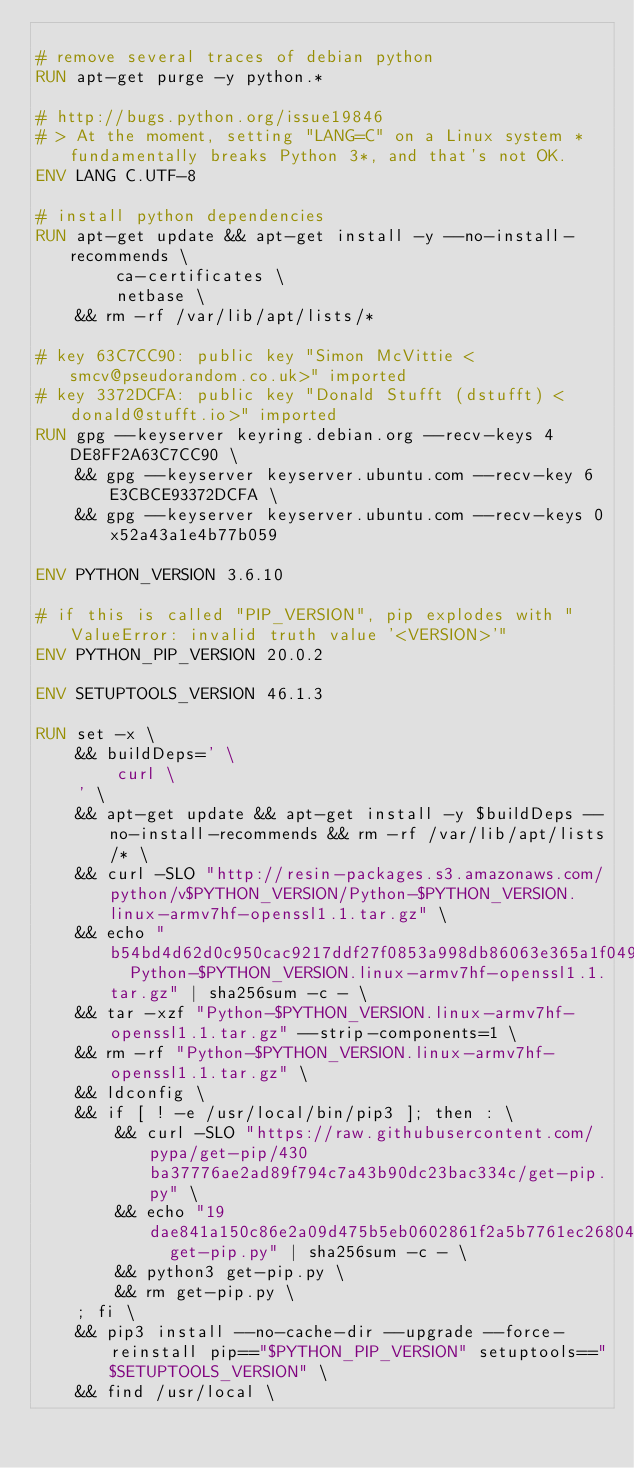<code> <loc_0><loc_0><loc_500><loc_500><_Dockerfile_>
# remove several traces of debian python
RUN apt-get purge -y python.*

# http://bugs.python.org/issue19846
# > At the moment, setting "LANG=C" on a Linux system *fundamentally breaks Python 3*, and that's not OK.
ENV LANG C.UTF-8

# install python dependencies
RUN apt-get update && apt-get install -y --no-install-recommends \
		ca-certificates \
		netbase \
	&& rm -rf /var/lib/apt/lists/*

# key 63C7CC90: public key "Simon McVittie <smcv@pseudorandom.co.uk>" imported
# key 3372DCFA: public key "Donald Stufft (dstufft) <donald@stufft.io>" imported
RUN gpg --keyserver keyring.debian.org --recv-keys 4DE8FF2A63C7CC90 \
	&& gpg --keyserver keyserver.ubuntu.com --recv-key 6E3CBCE93372DCFA \
	&& gpg --keyserver keyserver.ubuntu.com --recv-keys 0x52a43a1e4b77b059

ENV PYTHON_VERSION 3.6.10

# if this is called "PIP_VERSION", pip explodes with "ValueError: invalid truth value '<VERSION>'"
ENV PYTHON_PIP_VERSION 20.0.2

ENV SETUPTOOLS_VERSION 46.1.3

RUN set -x \
	&& buildDeps=' \
		curl \
	' \
	&& apt-get update && apt-get install -y $buildDeps --no-install-recommends && rm -rf /var/lib/apt/lists/* \
	&& curl -SLO "http://resin-packages.s3.amazonaws.com/python/v$PYTHON_VERSION/Python-$PYTHON_VERSION.linux-armv7hf-openssl1.1.tar.gz" \
	&& echo "b54bd4d62d0c950cac9217ddf27f0853a998db86063e365a1f0491f6029d04d5  Python-$PYTHON_VERSION.linux-armv7hf-openssl1.1.tar.gz" | sha256sum -c - \
	&& tar -xzf "Python-$PYTHON_VERSION.linux-armv7hf-openssl1.1.tar.gz" --strip-components=1 \
	&& rm -rf "Python-$PYTHON_VERSION.linux-armv7hf-openssl1.1.tar.gz" \
	&& ldconfig \
	&& if [ ! -e /usr/local/bin/pip3 ]; then : \
		&& curl -SLO "https://raw.githubusercontent.com/pypa/get-pip/430ba37776ae2ad89f794c7a43b90dc23bac334c/get-pip.py" \
		&& echo "19dae841a150c86e2a09d475b5eb0602861f2a5b7761ec268049a662dbd2bd0c  get-pip.py" | sha256sum -c - \
		&& python3 get-pip.py \
		&& rm get-pip.py \
	; fi \
	&& pip3 install --no-cache-dir --upgrade --force-reinstall pip=="$PYTHON_PIP_VERSION" setuptools=="$SETUPTOOLS_VERSION" \
	&& find /usr/local \</code> 